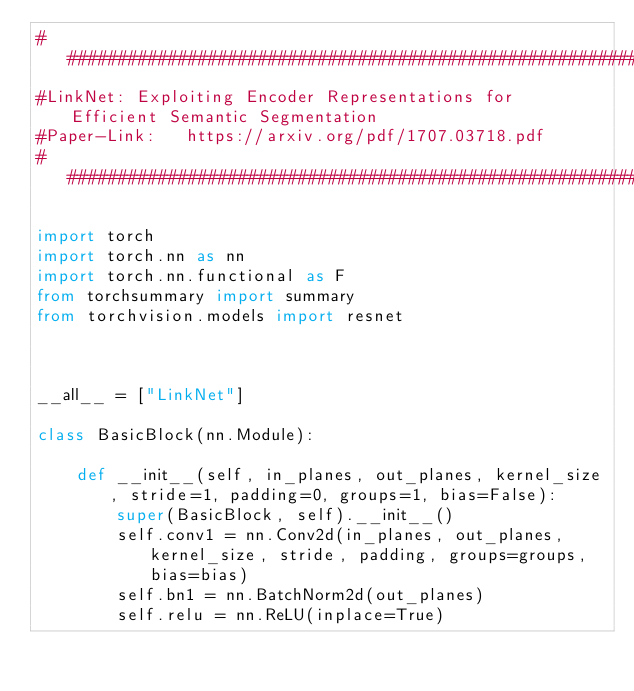<code> <loc_0><loc_0><loc_500><loc_500><_Python_>############################################################################################
#LinkNet: Exploiting Encoder Representations for Efficient Semantic Segmentation
#Paper-Link:   https://arxiv.org/pdf/1707.03718.pdf
############################################################################################

import torch
import torch.nn as nn
import torch.nn.functional as F
from torchsummary import summary
from torchvision.models import resnet



__all__ = ["LinkNet"]

class BasicBlock(nn.Module):

    def __init__(self, in_planes, out_planes, kernel_size, stride=1, padding=0, groups=1, bias=False):
        super(BasicBlock, self).__init__()
        self.conv1 = nn.Conv2d(in_planes, out_planes, kernel_size, stride, padding, groups=groups, bias=bias)
        self.bn1 = nn.BatchNorm2d(out_planes)
        self.relu = nn.ReLU(inplace=True)</code> 